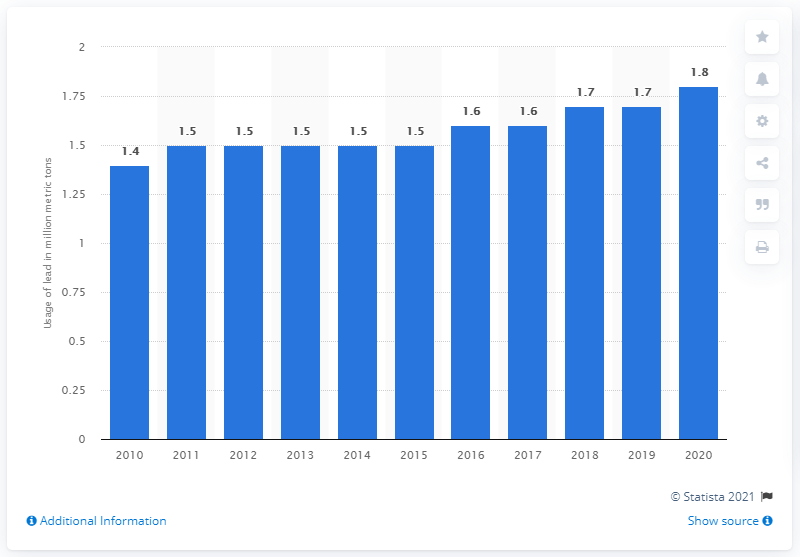Give some essential details in this illustration. It is projected that approximately 1.5 million pounds of lead will be used in the United States in 2017. 